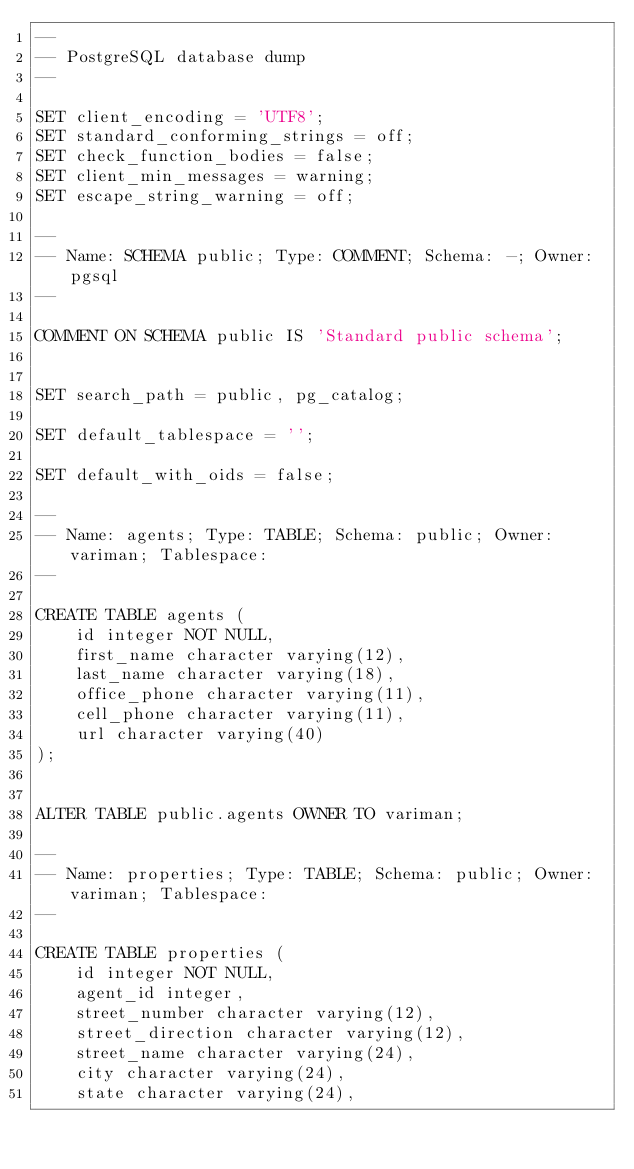<code> <loc_0><loc_0><loc_500><loc_500><_SQL_>--
-- PostgreSQL database dump
--

SET client_encoding = 'UTF8';
SET standard_conforming_strings = off;
SET check_function_bodies = false;
SET client_min_messages = warning;
SET escape_string_warning = off;

--
-- Name: SCHEMA public; Type: COMMENT; Schema: -; Owner: pgsql
--

COMMENT ON SCHEMA public IS 'Standard public schema';


SET search_path = public, pg_catalog;

SET default_tablespace = '';

SET default_with_oids = false;

--
-- Name: agents; Type: TABLE; Schema: public; Owner: variman; Tablespace: 
--

CREATE TABLE agents (
    id integer NOT NULL,
    first_name character varying(12),
    last_name character varying(18),
    office_phone character varying(11),
    cell_phone character varying(11),
    url character varying(40)
);


ALTER TABLE public.agents OWNER TO variman;

--
-- Name: properties; Type: TABLE; Schema: public; Owner: variman; Tablespace: 
--

CREATE TABLE properties (
    id integer NOT NULL,
    agent_id integer,
    street_number character varying(12),
    street_direction character varying(12),
    street_name character varying(24),
    city character varying(24),
    state character varying(24),</code> 